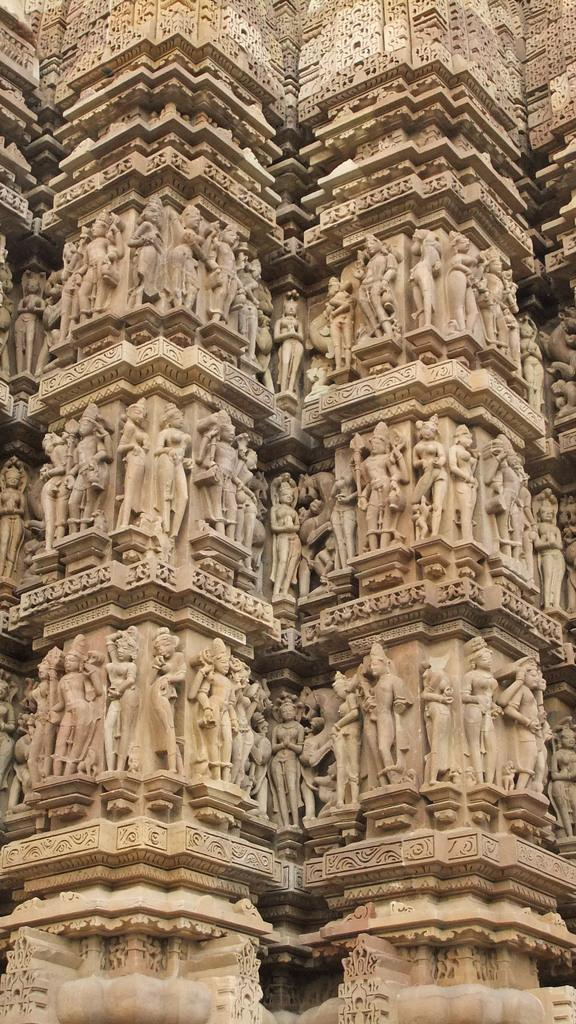What is the main subject of the image? The main subject of the image is a group of sculptures. What material are the sculptures made of? The sculptures are carved on a stone. What type of boot is being worn by the ants in the image? There are no ants or boots present in the image; it features a group of sculptures carved on a stone. 